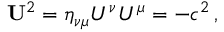Convert formula to latex. <formula><loc_0><loc_0><loc_500><loc_500>{ U } ^ { 2 } = \eta _ { \nu \mu } U ^ { \nu } U ^ { \mu } = - c ^ { 2 } \, ,</formula> 